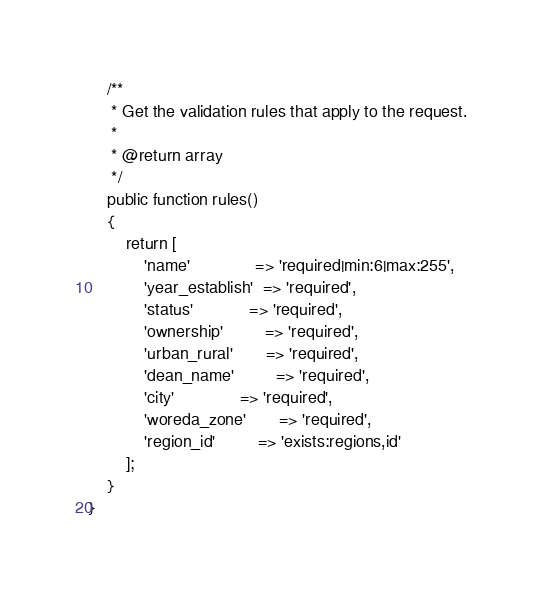<code> <loc_0><loc_0><loc_500><loc_500><_PHP_>
    /**
     * Get the validation rules that apply to the request.
     *
     * @return array
     */
    public function rules()
    {
        return [
            'name'              => 'required|min:6|max:255',
            'year_establish'  => 'required',
            'status'            => 'required',
            'ownership'         => 'required',
            'urban_rural'       => 'required',
            'dean_name'         => 'required',
            'city'              => 'required',
            'woreda_zone'       => 'required',
            'region_id'         => 'exists:regions,id'
        ];
    }
}
</code> 